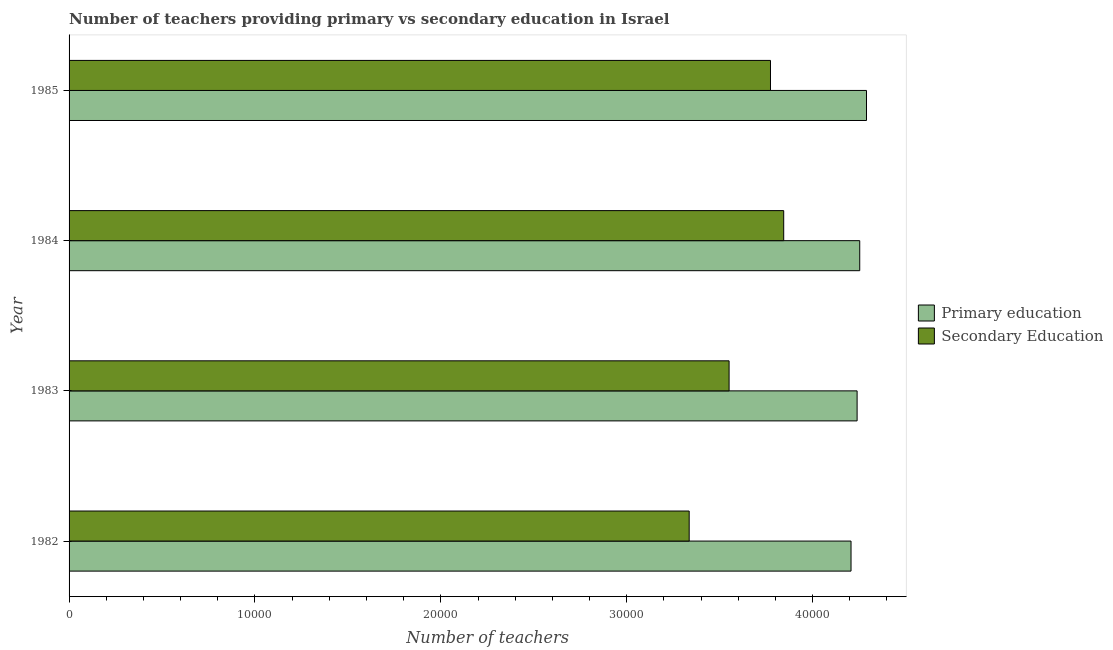How many different coloured bars are there?
Make the answer very short. 2. Are the number of bars per tick equal to the number of legend labels?
Provide a short and direct response. Yes. How many bars are there on the 2nd tick from the bottom?
Provide a short and direct response. 2. In how many cases, is the number of bars for a given year not equal to the number of legend labels?
Ensure brevity in your answer.  0. What is the number of secondary teachers in 1982?
Give a very brief answer. 3.34e+04. Across all years, what is the maximum number of primary teachers?
Keep it short and to the point. 4.29e+04. Across all years, what is the minimum number of primary teachers?
Offer a terse response. 4.21e+04. In which year was the number of secondary teachers maximum?
Give a very brief answer. 1984. What is the total number of primary teachers in the graph?
Your answer should be very brief. 1.70e+05. What is the difference between the number of secondary teachers in 1982 and that in 1984?
Give a very brief answer. -5085. What is the difference between the number of secondary teachers in 1984 and the number of primary teachers in 1982?
Offer a terse response. -3622. What is the average number of primary teachers per year?
Offer a very short reply. 4.25e+04. In the year 1982, what is the difference between the number of primary teachers and number of secondary teachers?
Keep it short and to the point. 8707. In how many years, is the number of primary teachers greater than 26000 ?
Your answer should be compact. 4. What is the ratio of the number of primary teachers in 1982 to that in 1985?
Your answer should be very brief. 0.98. Is the difference between the number of secondary teachers in 1982 and 1985 greater than the difference between the number of primary teachers in 1982 and 1985?
Provide a succinct answer. No. What is the difference between the highest and the second highest number of primary teachers?
Provide a succinct answer. 364. What is the difference between the highest and the lowest number of primary teachers?
Keep it short and to the point. 832. In how many years, is the number of secondary teachers greater than the average number of secondary teachers taken over all years?
Offer a terse response. 2. What does the 1st bar from the top in 1984 represents?
Your answer should be compact. Secondary Education. What does the 1st bar from the bottom in 1982 represents?
Give a very brief answer. Primary education. Are all the bars in the graph horizontal?
Offer a very short reply. Yes. How many years are there in the graph?
Offer a very short reply. 4. What is the difference between two consecutive major ticks on the X-axis?
Your response must be concise. 10000. Are the values on the major ticks of X-axis written in scientific E-notation?
Make the answer very short. No. Does the graph contain any zero values?
Ensure brevity in your answer.  No. Does the graph contain grids?
Provide a short and direct response. No. Where does the legend appear in the graph?
Your answer should be very brief. Center right. What is the title of the graph?
Your answer should be compact. Number of teachers providing primary vs secondary education in Israel. Does "Money lenders" appear as one of the legend labels in the graph?
Make the answer very short. No. What is the label or title of the X-axis?
Offer a very short reply. Number of teachers. What is the label or title of the Y-axis?
Ensure brevity in your answer.  Year. What is the Number of teachers of Primary education in 1982?
Make the answer very short. 4.21e+04. What is the Number of teachers of Secondary Education in 1982?
Keep it short and to the point. 3.34e+04. What is the Number of teachers in Primary education in 1983?
Your answer should be very brief. 4.24e+04. What is the Number of teachers in Secondary Education in 1983?
Ensure brevity in your answer.  3.55e+04. What is the Number of teachers in Primary education in 1984?
Offer a terse response. 4.25e+04. What is the Number of teachers in Secondary Education in 1984?
Ensure brevity in your answer.  3.84e+04. What is the Number of teachers of Primary education in 1985?
Offer a very short reply. 4.29e+04. What is the Number of teachers in Secondary Education in 1985?
Offer a terse response. 3.77e+04. Across all years, what is the maximum Number of teachers of Primary education?
Your answer should be compact. 4.29e+04. Across all years, what is the maximum Number of teachers in Secondary Education?
Your answer should be compact. 3.84e+04. Across all years, what is the minimum Number of teachers in Primary education?
Make the answer very short. 4.21e+04. Across all years, what is the minimum Number of teachers in Secondary Education?
Ensure brevity in your answer.  3.34e+04. What is the total Number of teachers of Primary education in the graph?
Your response must be concise. 1.70e+05. What is the total Number of teachers of Secondary Education in the graph?
Offer a terse response. 1.45e+05. What is the difference between the Number of teachers of Primary education in 1982 and that in 1983?
Keep it short and to the point. -327. What is the difference between the Number of teachers in Secondary Education in 1982 and that in 1983?
Keep it short and to the point. -2147. What is the difference between the Number of teachers in Primary education in 1982 and that in 1984?
Keep it short and to the point. -468. What is the difference between the Number of teachers in Secondary Education in 1982 and that in 1984?
Provide a short and direct response. -5085. What is the difference between the Number of teachers in Primary education in 1982 and that in 1985?
Offer a terse response. -832. What is the difference between the Number of teachers of Secondary Education in 1982 and that in 1985?
Provide a short and direct response. -4374. What is the difference between the Number of teachers in Primary education in 1983 and that in 1984?
Ensure brevity in your answer.  -141. What is the difference between the Number of teachers in Secondary Education in 1983 and that in 1984?
Your response must be concise. -2938. What is the difference between the Number of teachers of Primary education in 1983 and that in 1985?
Give a very brief answer. -505. What is the difference between the Number of teachers of Secondary Education in 1983 and that in 1985?
Your answer should be very brief. -2227. What is the difference between the Number of teachers of Primary education in 1984 and that in 1985?
Provide a short and direct response. -364. What is the difference between the Number of teachers of Secondary Education in 1984 and that in 1985?
Your answer should be very brief. 711. What is the difference between the Number of teachers of Primary education in 1982 and the Number of teachers of Secondary Education in 1983?
Provide a short and direct response. 6560. What is the difference between the Number of teachers of Primary education in 1982 and the Number of teachers of Secondary Education in 1984?
Your response must be concise. 3622. What is the difference between the Number of teachers of Primary education in 1982 and the Number of teachers of Secondary Education in 1985?
Offer a terse response. 4333. What is the difference between the Number of teachers in Primary education in 1983 and the Number of teachers in Secondary Education in 1984?
Make the answer very short. 3949. What is the difference between the Number of teachers in Primary education in 1983 and the Number of teachers in Secondary Education in 1985?
Your response must be concise. 4660. What is the difference between the Number of teachers of Primary education in 1984 and the Number of teachers of Secondary Education in 1985?
Keep it short and to the point. 4801. What is the average Number of teachers in Primary education per year?
Your answer should be very brief. 4.25e+04. What is the average Number of teachers of Secondary Education per year?
Offer a terse response. 3.63e+04. In the year 1982, what is the difference between the Number of teachers of Primary education and Number of teachers of Secondary Education?
Provide a short and direct response. 8707. In the year 1983, what is the difference between the Number of teachers of Primary education and Number of teachers of Secondary Education?
Give a very brief answer. 6887. In the year 1984, what is the difference between the Number of teachers in Primary education and Number of teachers in Secondary Education?
Offer a very short reply. 4090. In the year 1985, what is the difference between the Number of teachers of Primary education and Number of teachers of Secondary Education?
Ensure brevity in your answer.  5165. What is the ratio of the Number of teachers of Secondary Education in 1982 to that in 1983?
Offer a very short reply. 0.94. What is the ratio of the Number of teachers of Secondary Education in 1982 to that in 1984?
Offer a terse response. 0.87. What is the ratio of the Number of teachers of Primary education in 1982 to that in 1985?
Ensure brevity in your answer.  0.98. What is the ratio of the Number of teachers of Secondary Education in 1982 to that in 1985?
Make the answer very short. 0.88. What is the ratio of the Number of teachers of Primary education in 1983 to that in 1984?
Offer a terse response. 1. What is the ratio of the Number of teachers in Secondary Education in 1983 to that in 1984?
Make the answer very short. 0.92. What is the ratio of the Number of teachers of Primary education in 1983 to that in 1985?
Your answer should be very brief. 0.99. What is the ratio of the Number of teachers in Secondary Education in 1983 to that in 1985?
Your answer should be very brief. 0.94. What is the ratio of the Number of teachers of Primary education in 1984 to that in 1985?
Make the answer very short. 0.99. What is the ratio of the Number of teachers in Secondary Education in 1984 to that in 1985?
Make the answer very short. 1.02. What is the difference between the highest and the second highest Number of teachers of Primary education?
Make the answer very short. 364. What is the difference between the highest and the second highest Number of teachers in Secondary Education?
Provide a succinct answer. 711. What is the difference between the highest and the lowest Number of teachers in Primary education?
Make the answer very short. 832. What is the difference between the highest and the lowest Number of teachers in Secondary Education?
Keep it short and to the point. 5085. 